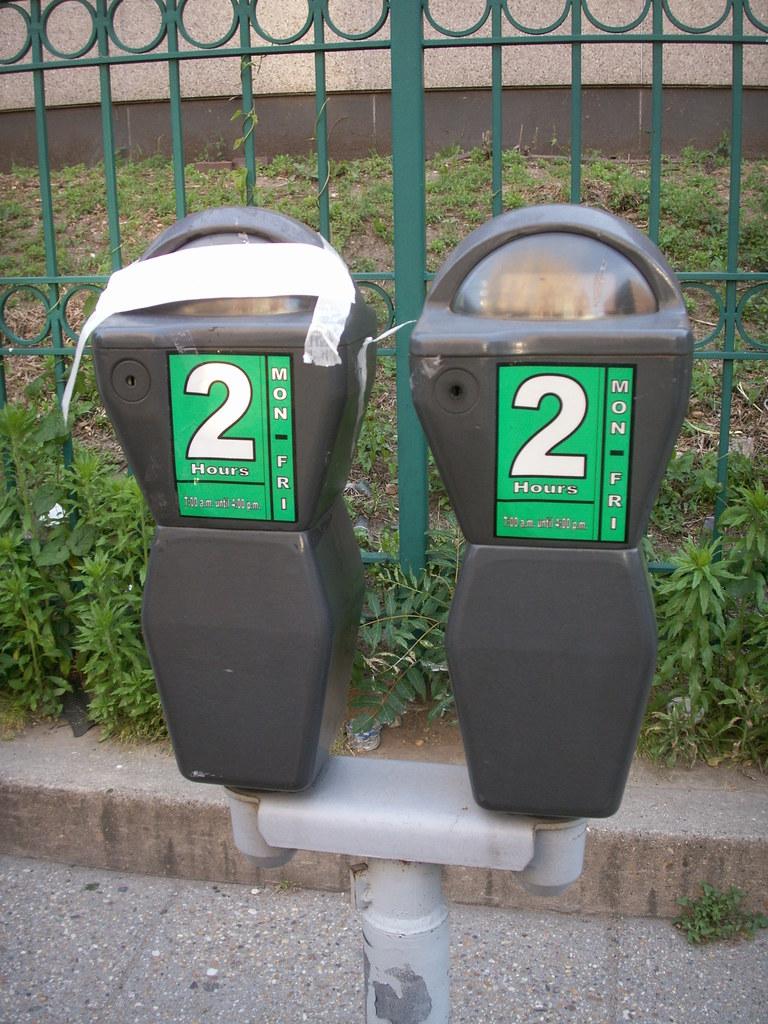How long can you park?
Make the answer very short. 2 hours. 